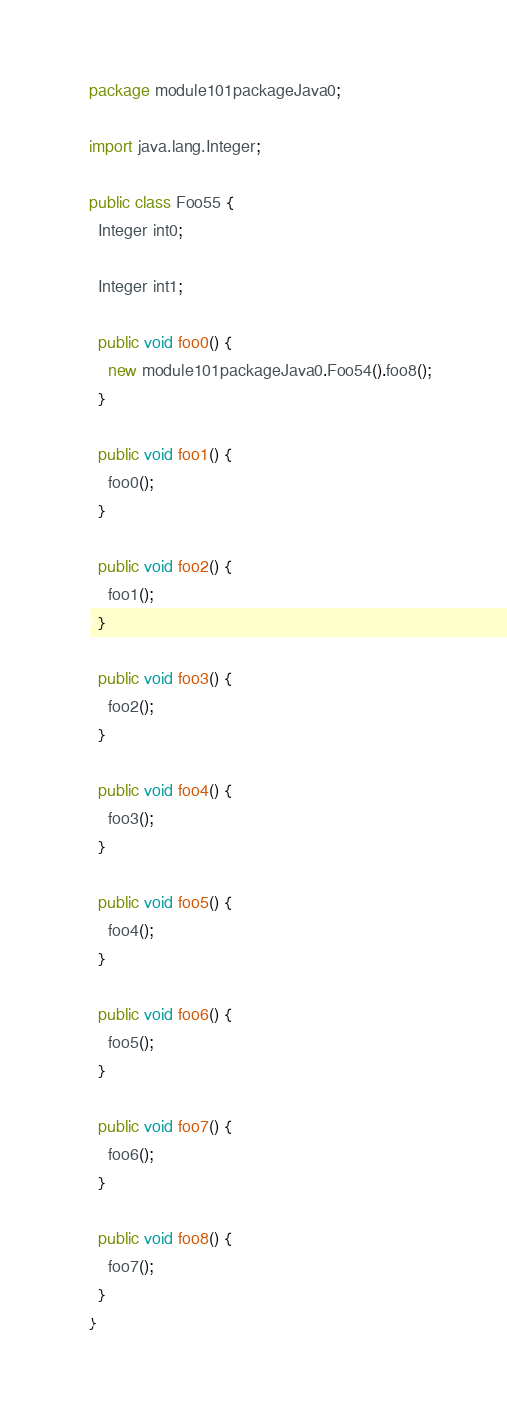Convert code to text. <code><loc_0><loc_0><loc_500><loc_500><_Java_>package module101packageJava0;

import java.lang.Integer;

public class Foo55 {
  Integer int0;

  Integer int1;

  public void foo0() {
    new module101packageJava0.Foo54().foo8();
  }

  public void foo1() {
    foo0();
  }

  public void foo2() {
    foo1();
  }

  public void foo3() {
    foo2();
  }

  public void foo4() {
    foo3();
  }

  public void foo5() {
    foo4();
  }

  public void foo6() {
    foo5();
  }

  public void foo7() {
    foo6();
  }

  public void foo8() {
    foo7();
  }
}
</code> 